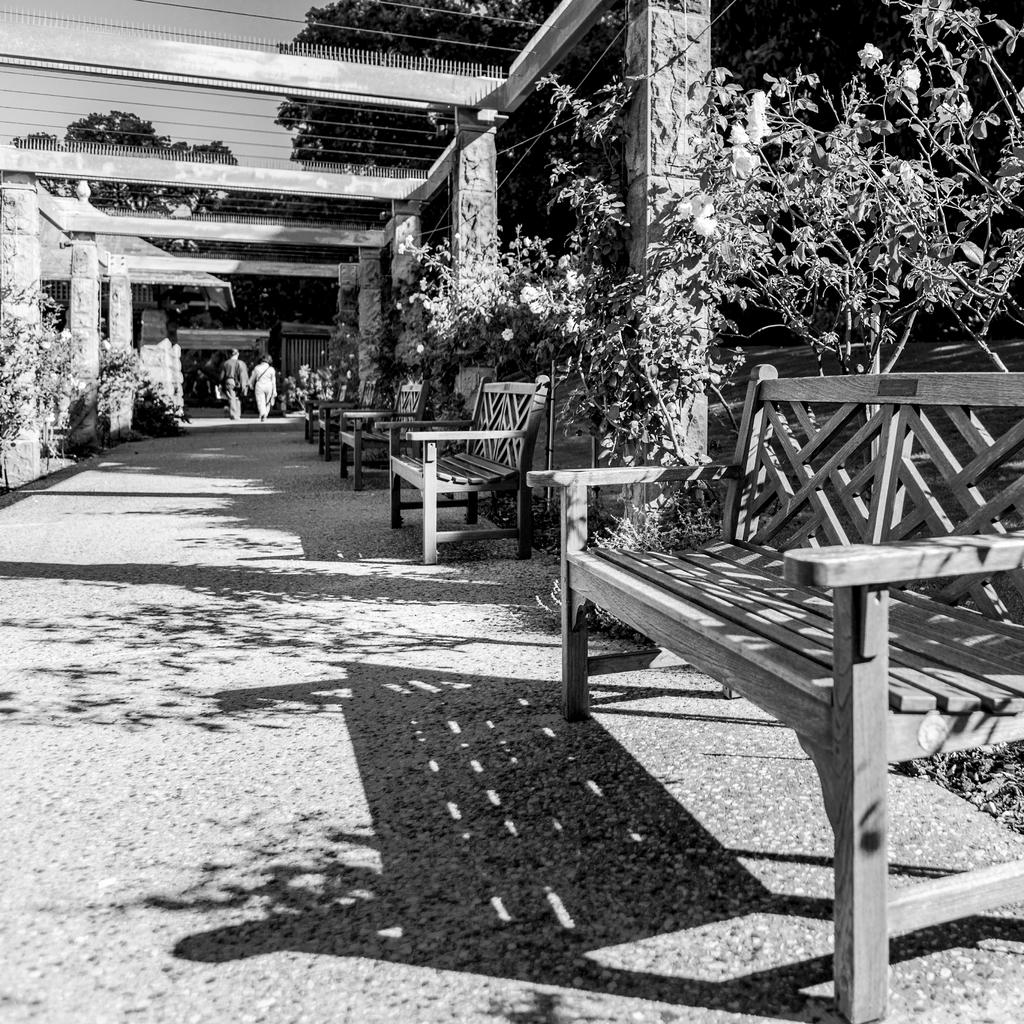What are the two people in the image doing? The two people in the image are walking in the center of the image. What can be seen on the right side of the image? There are benches on the right side of the image. What type of vegetation is visible in the image? There are plants visible in the image. What architectural features can be seen in the background of the image? There are arches in the background of the image. What else is visible in the background of the image? Trees, wires, and the sky are visible in the background of the image. What type of jeans is the sky wearing in the image? The sky is not wearing jeans, as the sky is a celestial body and not a person. 